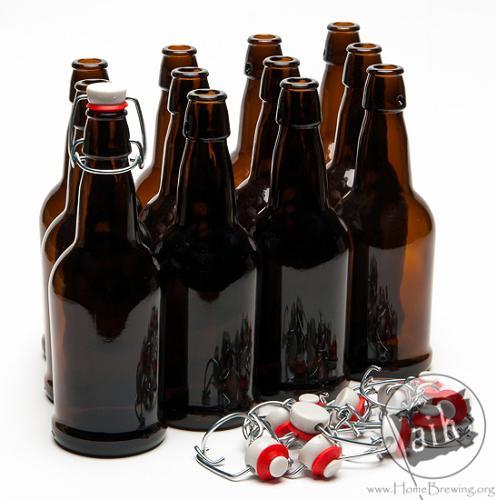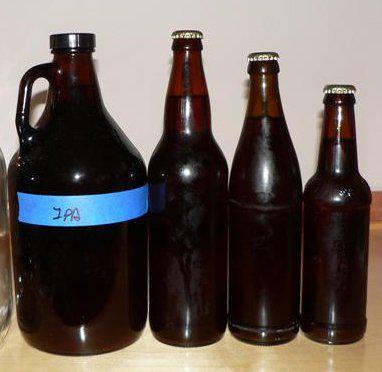The first image is the image on the left, the second image is the image on the right. Given the left and right images, does the statement "One image shows rows of four bottles three deep." hold true? Answer yes or no. Yes. 